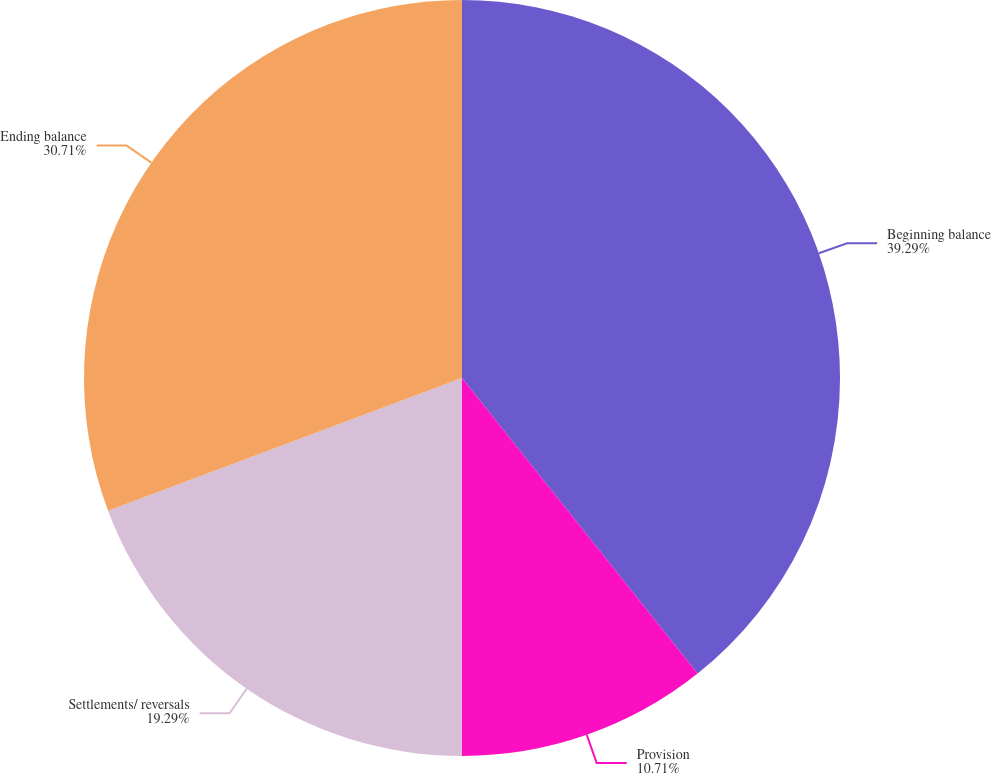Convert chart. <chart><loc_0><loc_0><loc_500><loc_500><pie_chart><fcel>Beginning balance<fcel>Provision<fcel>Settlements/ reversals<fcel>Ending balance<nl><fcel>39.29%<fcel>10.71%<fcel>19.29%<fcel>30.71%<nl></chart> 